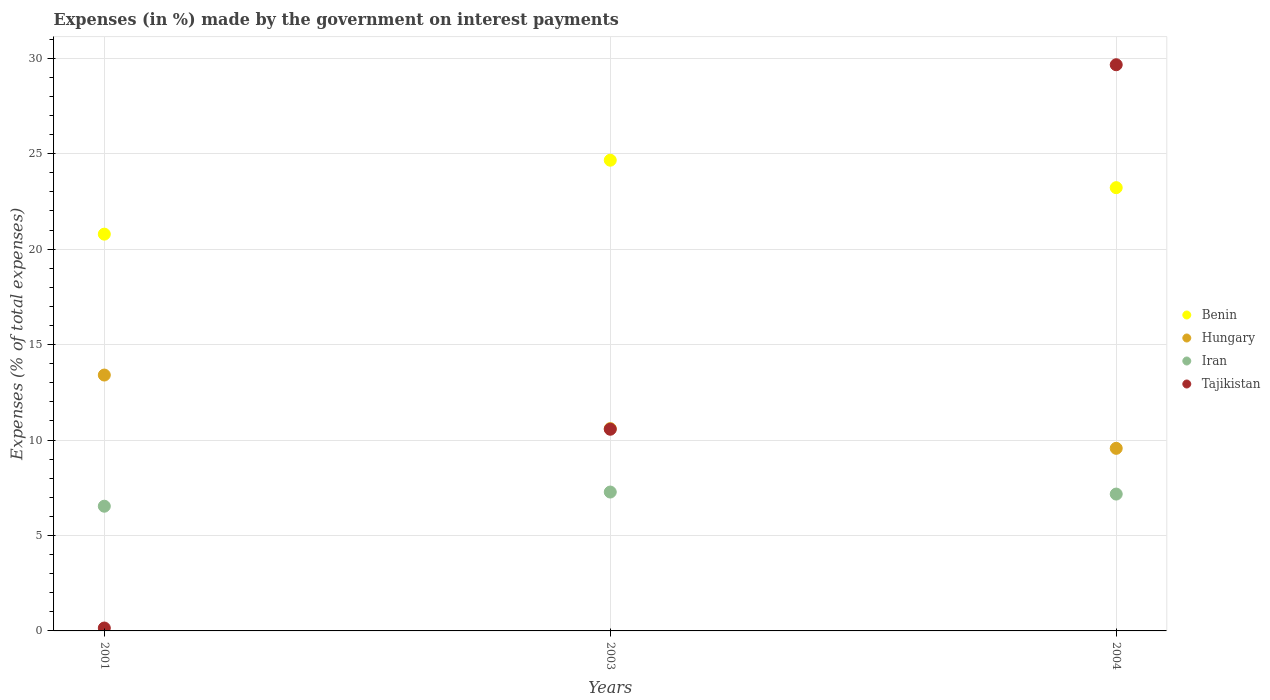How many different coloured dotlines are there?
Make the answer very short. 4. What is the percentage of expenses made by the government on interest payments in Tajikistan in 2001?
Give a very brief answer. 0.15. Across all years, what is the maximum percentage of expenses made by the government on interest payments in Hungary?
Your answer should be compact. 13.41. Across all years, what is the minimum percentage of expenses made by the government on interest payments in Tajikistan?
Offer a terse response. 0.15. In which year was the percentage of expenses made by the government on interest payments in Tajikistan maximum?
Your answer should be very brief. 2004. What is the total percentage of expenses made by the government on interest payments in Hungary in the graph?
Your response must be concise. 33.57. What is the difference between the percentage of expenses made by the government on interest payments in Benin in 2001 and that in 2004?
Your answer should be compact. -2.44. What is the difference between the percentage of expenses made by the government on interest payments in Iran in 2004 and the percentage of expenses made by the government on interest payments in Benin in 2001?
Ensure brevity in your answer.  -13.62. What is the average percentage of expenses made by the government on interest payments in Benin per year?
Offer a terse response. 22.89. In the year 2001, what is the difference between the percentage of expenses made by the government on interest payments in Iran and percentage of expenses made by the government on interest payments in Benin?
Your answer should be compact. -14.25. What is the ratio of the percentage of expenses made by the government on interest payments in Hungary in 2001 to that in 2003?
Offer a terse response. 1.26. Is the percentage of expenses made by the government on interest payments in Iran in 2003 less than that in 2004?
Provide a succinct answer. No. Is the difference between the percentage of expenses made by the government on interest payments in Iran in 2001 and 2004 greater than the difference between the percentage of expenses made by the government on interest payments in Benin in 2001 and 2004?
Offer a terse response. Yes. What is the difference between the highest and the second highest percentage of expenses made by the government on interest payments in Benin?
Make the answer very short. 1.44. What is the difference between the highest and the lowest percentage of expenses made by the government on interest payments in Hungary?
Your response must be concise. 3.84. Is it the case that in every year, the sum of the percentage of expenses made by the government on interest payments in Tajikistan and percentage of expenses made by the government on interest payments in Hungary  is greater than the percentage of expenses made by the government on interest payments in Benin?
Keep it short and to the point. No. Is the percentage of expenses made by the government on interest payments in Iran strictly greater than the percentage of expenses made by the government on interest payments in Tajikistan over the years?
Offer a very short reply. No. Is the percentage of expenses made by the government on interest payments in Benin strictly less than the percentage of expenses made by the government on interest payments in Hungary over the years?
Your answer should be very brief. No. How many dotlines are there?
Give a very brief answer. 4. What is the difference between two consecutive major ticks on the Y-axis?
Offer a terse response. 5. Does the graph contain any zero values?
Keep it short and to the point. No. Where does the legend appear in the graph?
Offer a very short reply. Center right. How many legend labels are there?
Your response must be concise. 4. What is the title of the graph?
Keep it short and to the point. Expenses (in %) made by the government on interest payments. Does "France" appear as one of the legend labels in the graph?
Ensure brevity in your answer.  No. What is the label or title of the Y-axis?
Your answer should be compact. Expenses (% of total expenses). What is the Expenses (% of total expenses) of Benin in 2001?
Offer a very short reply. 20.79. What is the Expenses (% of total expenses) in Hungary in 2001?
Ensure brevity in your answer.  13.41. What is the Expenses (% of total expenses) in Iran in 2001?
Provide a short and direct response. 6.53. What is the Expenses (% of total expenses) in Tajikistan in 2001?
Keep it short and to the point. 0.15. What is the Expenses (% of total expenses) in Benin in 2003?
Make the answer very short. 24.66. What is the Expenses (% of total expenses) of Hungary in 2003?
Your answer should be very brief. 10.6. What is the Expenses (% of total expenses) of Iran in 2003?
Provide a succinct answer. 7.28. What is the Expenses (% of total expenses) of Tajikistan in 2003?
Give a very brief answer. 10.57. What is the Expenses (% of total expenses) in Benin in 2004?
Keep it short and to the point. 23.22. What is the Expenses (% of total expenses) of Hungary in 2004?
Provide a succinct answer. 9.57. What is the Expenses (% of total expenses) of Iran in 2004?
Give a very brief answer. 7.17. What is the Expenses (% of total expenses) in Tajikistan in 2004?
Your answer should be compact. 29.66. Across all years, what is the maximum Expenses (% of total expenses) in Benin?
Your response must be concise. 24.66. Across all years, what is the maximum Expenses (% of total expenses) in Hungary?
Offer a very short reply. 13.41. Across all years, what is the maximum Expenses (% of total expenses) in Iran?
Provide a short and direct response. 7.28. Across all years, what is the maximum Expenses (% of total expenses) of Tajikistan?
Your answer should be compact. 29.66. Across all years, what is the minimum Expenses (% of total expenses) of Benin?
Offer a very short reply. 20.79. Across all years, what is the minimum Expenses (% of total expenses) of Hungary?
Ensure brevity in your answer.  9.57. Across all years, what is the minimum Expenses (% of total expenses) of Iran?
Provide a short and direct response. 6.53. Across all years, what is the minimum Expenses (% of total expenses) of Tajikistan?
Offer a terse response. 0.15. What is the total Expenses (% of total expenses) of Benin in the graph?
Offer a terse response. 68.67. What is the total Expenses (% of total expenses) of Hungary in the graph?
Your answer should be compact. 33.57. What is the total Expenses (% of total expenses) of Iran in the graph?
Provide a succinct answer. 20.98. What is the total Expenses (% of total expenses) in Tajikistan in the graph?
Offer a very short reply. 40.38. What is the difference between the Expenses (% of total expenses) of Benin in 2001 and that in 2003?
Your answer should be very brief. -3.87. What is the difference between the Expenses (% of total expenses) in Hungary in 2001 and that in 2003?
Make the answer very short. 2.8. What is the difference between the Expenses (% of total expenses) in Iran in 2001 and that in 2003?
Offer a terse response. -0.74. What is the difference between the Expenses (% of total expenses) of Tajikistan in 2001 and that in 2003?
Offer a terse response. -10.41. What is the difference between the Expenses (% of total expenses) of Benin in 2001 and that in 2004?
Make the answer very short. -2.44. What is the difference between the Expenses (% of total expenses) of Hungary in 2001 and that in 2004?
Provide a succinct answer. 3.84. What is the difference between the Expenses (% of total expenses) of Iran in 2001 and that in 2004?
Ensure brevity in your answer.  -0.64. What is the difference between the Expenses (% of total expenses) in Tajikistan in 2001 and that in 2004?
Make the answer very short. -29.51. What is the difference between the Expenses (% of total expenses) in Benin in 2003 and that in 2004?
Ensure brevity in your answer.  1.44. What is the difference between the Expenses (% of total expenses) of Hungary in 2003 and that in 2004?
Provide a short and direct response. 1.03. What is the difference between the Expenses (% of total expenses) in Iran in 2003 and that in 2004?
Offer a terse response. 0.11. What is the difference between the Expenses (% of total expenses) of Tajikistan in 2003 and that in 2004?
Your response must be concise. -19.1. What is the difference between the Expenses (% of total expenses) of Benin in 2001 and the Expenses (% of total expenses) of Hungary in 2003?
Give a very brief answer. 10.19. What is the difference between the Expenses (% of total expenses) of Benin in 2001 and the Expenses (% of total expenses) of Iran in 2003?
Offer a terse response. 13.51. What is the difference between the Expenses (% of total expenses) of Benin in 2001 and the Expenses (% of total expenses) of Tajikistan in 2003?
Offer a very short reply. 10.22. What is the difference between the Expenses (% of total expenses) in Hungary in 2001 and the Expenses (% of total expenses) in Iran in 2003?
Your answer should be very brief. 6.13. What is the difference between the Expenses (% of total expenses) of Hungary in 2001 and the Expenses (% of total expenses) of Tajikistan in 2003?
Give a very brief answer. 2.84. What is the difference between the Expenses (% of total expenses) in Iran in 2001 and the Expenses (% of total expenses) in Tajikistan in 2003?
Provide a short and direct response. -4.03. What is the difference between the Expenses (% of total expenses) of Benin in 2001 and the Expenses (% of total expenses) of Hungary in 2004?
Provide a short and direct response. 11.22. What is the difference between the Expenses (% of total expenses) in Benin in 2001 and the Expenses (% of total expenses) in Iran in 2004?
Your answer should be compact. 13.62. What is the difference between the Expenses (% of total expenses) of Benin in 2001 and the Expenses (% of total expenses) of Tajikistan in 2004?
Make the answer very short. -8.88. What is the difference between the Expenses (% of total expenses) of Hungary in 2001 and the Expenses (% of total expenses) of Iran in 2004?
Your response must be concise. 6.24. What is the difference between the Expenses (% of total expenses) of Hungary in 2001 and the Expenses (% of total expenses) of Tajikistan in 2004?
Give a very brief answer. -16.26. What is the difference between the Expenses (% of total expenses) in Iran in 2001 and the Expenses (% of total expenses) in Tajikistan in 2004?
Make the answer very short. -23.13. What is the difference between the Expenses (% of total expenses) of Benin in 2003 and the Expenses (% of total expenses) of Hungary in 2004?
Keep it short and to the point. 15.1. What is the difference between the Expenses (% of total expenses) in Benin in 2003 and the Expenses (% of total expenses) in Iran in 2004?
Provide a short and direct response. 17.49. What is the difference between the Expenses (% of total expenses) of Benin in 2003 and the Expenses (% of total expenses) of Tajikistan in 2004?
Your answer should be compact. -5. What is the difference between the Expenses (% of total expenses) of Hungary in 2003 and the Expenses (% of total expenses) of Iran in 2004?
Offer a very short reply. 3.43. What is the difference between the Expenses (% of total expenses) in Hungary in 2003 and the Expenses (% of total expenses) in Tajikistan in 2004?
Your answer should be compact. -19.06. What is the difference between the Expenses (% of total expenses) of Iran in 2003 and the Expenses (% of total expenses) of Tajikistan in 2004?
Make the answer very short. -22.39. What is the average Expenses (% of total expenses) of Benin per year?
Provide a short and direct response. 22.89. What is the average Expenses (% of total expenses) of Hungary per year?
Offer a very short reply. 11.19. What is the average Expenses (% of total expenses) in Iran per year?
Make the answer very short. 6.99. What is the average Expenses (% of total expenses) in Tajikistan per year?
Offer a terse response. 13.46. In the year 2001, what is the difference between the Expenses (% of total expenses) in Benin and Expenses (% of total expenses) in Hungary?
Your answer should be compact. 7.38. In the year 2001, what is the difference between the Expenses (% of total expenses) in Benin and Expenses (% of total expenses) in Iran?
Give a very brief answer. 14.25. In the year 2001, what is the difference between the Expenses (% of total expenses) in Benin and Expenses (% of total expenses) in Tajikistan?
Make the answer very short. 20.63. In the year 2001, what is the difference between the Expenses (% of total expenses) of Hungary and Expenses (% of total expenses) of Iran?
Give a very brief answer. 6.87. In the year 2001, what is the difference between the Expenses (% of total expenses) in Hungary and Expenses (% of total expenses) in Tajikistan?
Offer a terse response. 13.25. In the year 2001, what is the difference between the Expenses (% of total expenses) in Iran and Expenses (% of total expenses) in Tajikistan?
Your answer should be compact. 6.38. In the year 2003, what is the difference between the Expenses (% of total expenses) in Benin and Expenses (% of total expenses) in Hungary?
Your answer should be compact. 14.06. In the year 2003, what is the difference between the Expenses (% of total expenses) of Benin and Expenses (% of total expenses) of Iran?
Your response must be concise. 17.38. In the year 2003, what is the difference between the Expenses (% of total expenses) in Benin and Expenses (% of total expenses) in Tajikistan?
Offer a terse response. 14.1. In the year 2003, what is the difference between the Expenses (% of total expenses) of Hungary and Expenses (% of total expenses) of Iran?
Your response must be concise. 3.32. In the year 2003, what is the difference between the Expenses (% of total expenses) in Hungary and Expenses (% of total expenses) in Tajikistan?
Provide a succinct answer. 0.04. In the year 2003, what is the difference between the Expenses (% of total expenses) in Iran and Expenses (% of total expenses) in Tajikistan?
Provide a succinct answer. -3.29. In the year 2004, what is the difference between the Expenses (% of total expenses) in Benin and Expenses (% of total expenses) in Hungary?
Provide a short and direct response. 13.66. In the year 2004, what is the difference between the Expenses (% of total expenses) of Benin and Expenses (% of total expenses) of Iran?
Your answer should be compact. 16.05. In the year 2004, what is the difference between the Expenses (% of total expenses) of Benin and Expenses (% of total expenses) of Tajikistan?
Make the answer very short. -6.44. In the year 2004, what is the difference between the Expenses (% of total expenses) in Hungary and Expenses (% of total expenses) in Iran?
Provide a short and direct response. 2.4. In the year 2004, what is the difference between the Expenses (% of total expenses) of Hungary and Expenses (% of total expenses) of Tajikistan?
Offer a very short reply. -20.1. In the year 2004, what is the difference between the Expenses (% of total expenses) of Iran and Expenses (% of total expenses) of Tajikistan?
Offer a terse response. -22.49. What is the ratio of the Expenses (% of total expenses) of Benin in 2001 to that in 2003?
Your answer should be very brief. 0.84. What is the ratio of the Expenses (% of total expenses) of Hungary in 2001 to that in 2003?
Your answer should be compact. 1.26. What is the ratio of the Expenses (% of total expenses) in Iran in 2001 to that in 2003?
Offer a terse response. 0.9. What is the ratio of the Expenses (% of total expenses) of Tajikistan in 2001 to that in 2003?
Your answer should be compact. 0.01. What is the ratio of the Expenses (% of total expenses) of Benin in 2001 to that in 2004?
Keep it short and to the point. 0.9. What is the ratio of the Expenses (% of total expenses) of Hungary in 2001 to that in 2004?
Provide a succinct answer. 1.4. What is the ratio of the Expenses (% of total expenses) in Iran in 2001 to that in 2004?
Your response must be concise. 0.91. What is the ratio of the Expenses (% of total expenses) in Tajikistan in 2001 to that in 2004?
Make the answer very short. 0.01. What is the ratio of the Expenses (% of total expenses) in Benin in 2003 to that in 2004?
Provide a short and direct response. 1.06. What is the ratio of the Expenses (% of total expenses) in Hungary in 2003 to that in 2004?
Your answer should be very brief. 1.11. What is the ratio of the Expenses (% of total expenses) in Iran in 2003 to that in 2004?
Your answer should be very brief. 1.01. What is the ratio of the Expenses (% of total expenses) in Tajikistan in 2003 to that in 2004?
Provide a succinct answer. 0.36. What is the difference between the highest and the second highest Expenses (% of total expenses) in Benin?
Provide a succinct answer. 1.44. What is the difference between the highest and the second highest Expenses (% of total expenses) of Hungary?
Your response must be concise. 2.8. What is the difference between the highest and the second highest Expenses (% of total expenses) of Iran?
Give a very brief answer. 0.11. What is the difference between the highest and the second highest Expenses (% of total expenses) of Tajikistan?
Make the answer very short. 19.1. What is the difference between the highest and the lowest Expenses (% of total expenses) of Benin?
Your answer should be compact. 3.87. What is the difference between the highest and the lowest Expenses (% of total expenses) of Hungary?
Make the answer very short. 3.84. What is the difference between the highest and the lowest Expenses (% of total expenses) in Iran?
Your response must be concise. 0.74. What is the difference between the highest and the lowest Expenses (% of total expenses) of Tajikistan?
Your answer should be compact. 29.51. 